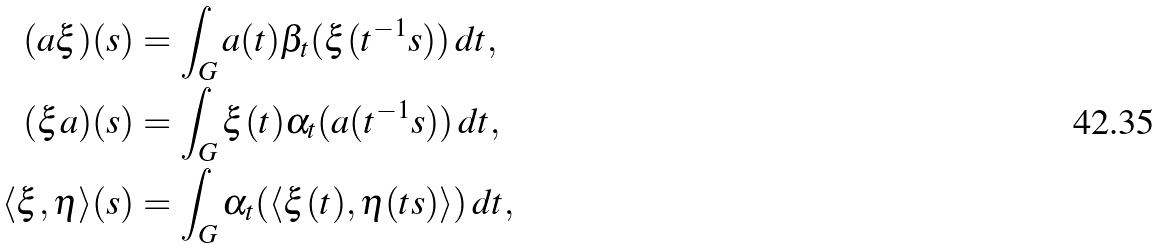Convert formula to latex. <formula><loc_0><loc_0><loc_500><loc_500>( a \xi ) ( s ) & = \int _ { G } a ( t ) \beta _ { t } ( \xi ( t ^ { - 1 } s ) ) \, d t , \\ ( \xi a ) ( s ) & = \int _ { G } \xi ( t ) \alpha _ { t } ( a ( t ^ { - 1 } s ) ) \, d t , \\ \langle \xi , \eta \rangle ( s ) & = \int _ { G } \alpha _ { t } ( \langle \xi ( t ) , \eta ( t s ) \rangle ) \, d t ,</formula> 